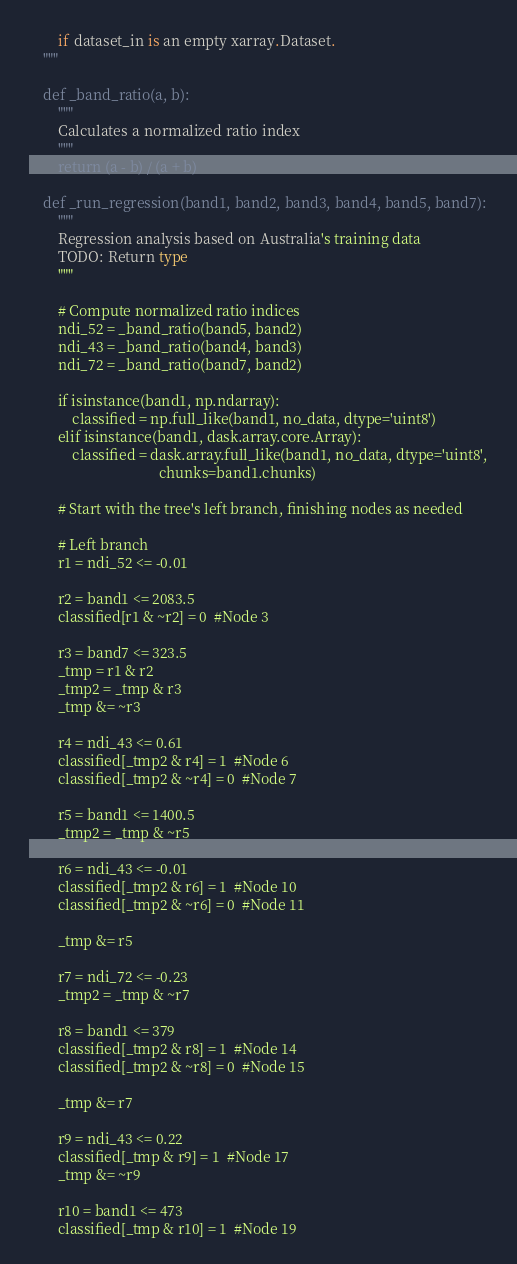Convert code to text. <code><loc_0><loc_0><loc_500><loc_500><_Python_>        if dataset_in is an empty xarray.Dataset.
    """

    def _band_ratio(a, b):
        """
        Calculates a normalized ratio index
        """
        return (a - b) / (a + b)

    def _run_regression(band1, band2, band3, band4, band5, band7):
        """
        Regression analysis based on Australia's training data
        TODO: Return type
        """

        # Compute normalized ratio indices
        ndi_52 = _band_ratio(band5, band2)
        ndi_43 = _band_ratio(band4, band3)
        ndi_72 = _band_ratio(band7, band2)

        if isinstance(band1, np.ndarray):
            classified = np.full_like(band1, no_data, dtype='uint8')
        elif isinstance(band1, dask.array.core.Array):
            classified = dask.array.full_like(band1, no_data, dtype='uint8',
                                    chunks=band1.chunks)
    
        # Start with the tree's left branch, finishing nodes as needed

        # Left branch
        r1 = ndi_52 <= -0.01

        r2 = band1 <= 2083.5
        classified[r1 & ~r2] = 0  #Node 3

        r3 = band7 <= 323.5
        _tmp = r1 & r2
        _tmp2 = _tmp & r3
        _tmp &= ~r3

        r4 = ndi_43 <= 0.61
        classified[_tmp2 & r4] = 1  #Node 6
        classified[_tmp2 & ~r4] = 0  #Node 7

        r5 = band1 <= 1400.5
        _tmp2 = _tmp & ~r5

        r6 = ndi_43 <= -0.01
        classified[_tmp2 & r6] = 1  #Node 10
        classified[_tmp2 & ~r6] = 0  #Node 11

        _tmp &= r5

        r7 = ndi_72 <= -0.23
        _tmp2 = _tmp & ~r7

        r8 = band1 <= 379
        classified[_tmp2 & r8] = 1  #Node 14
        classified[_tmp2 & ~r8] = 0  #Node 15

        _tmp &= r7

        r9 = ndi_43 <= 0.22
        classified[_tmp & r9] = 1  #Node 17
        _tmp &= ~r9

        r10 = band1 <= 473
        classified[_tmp & r10] = 1  #Node 19</code> 